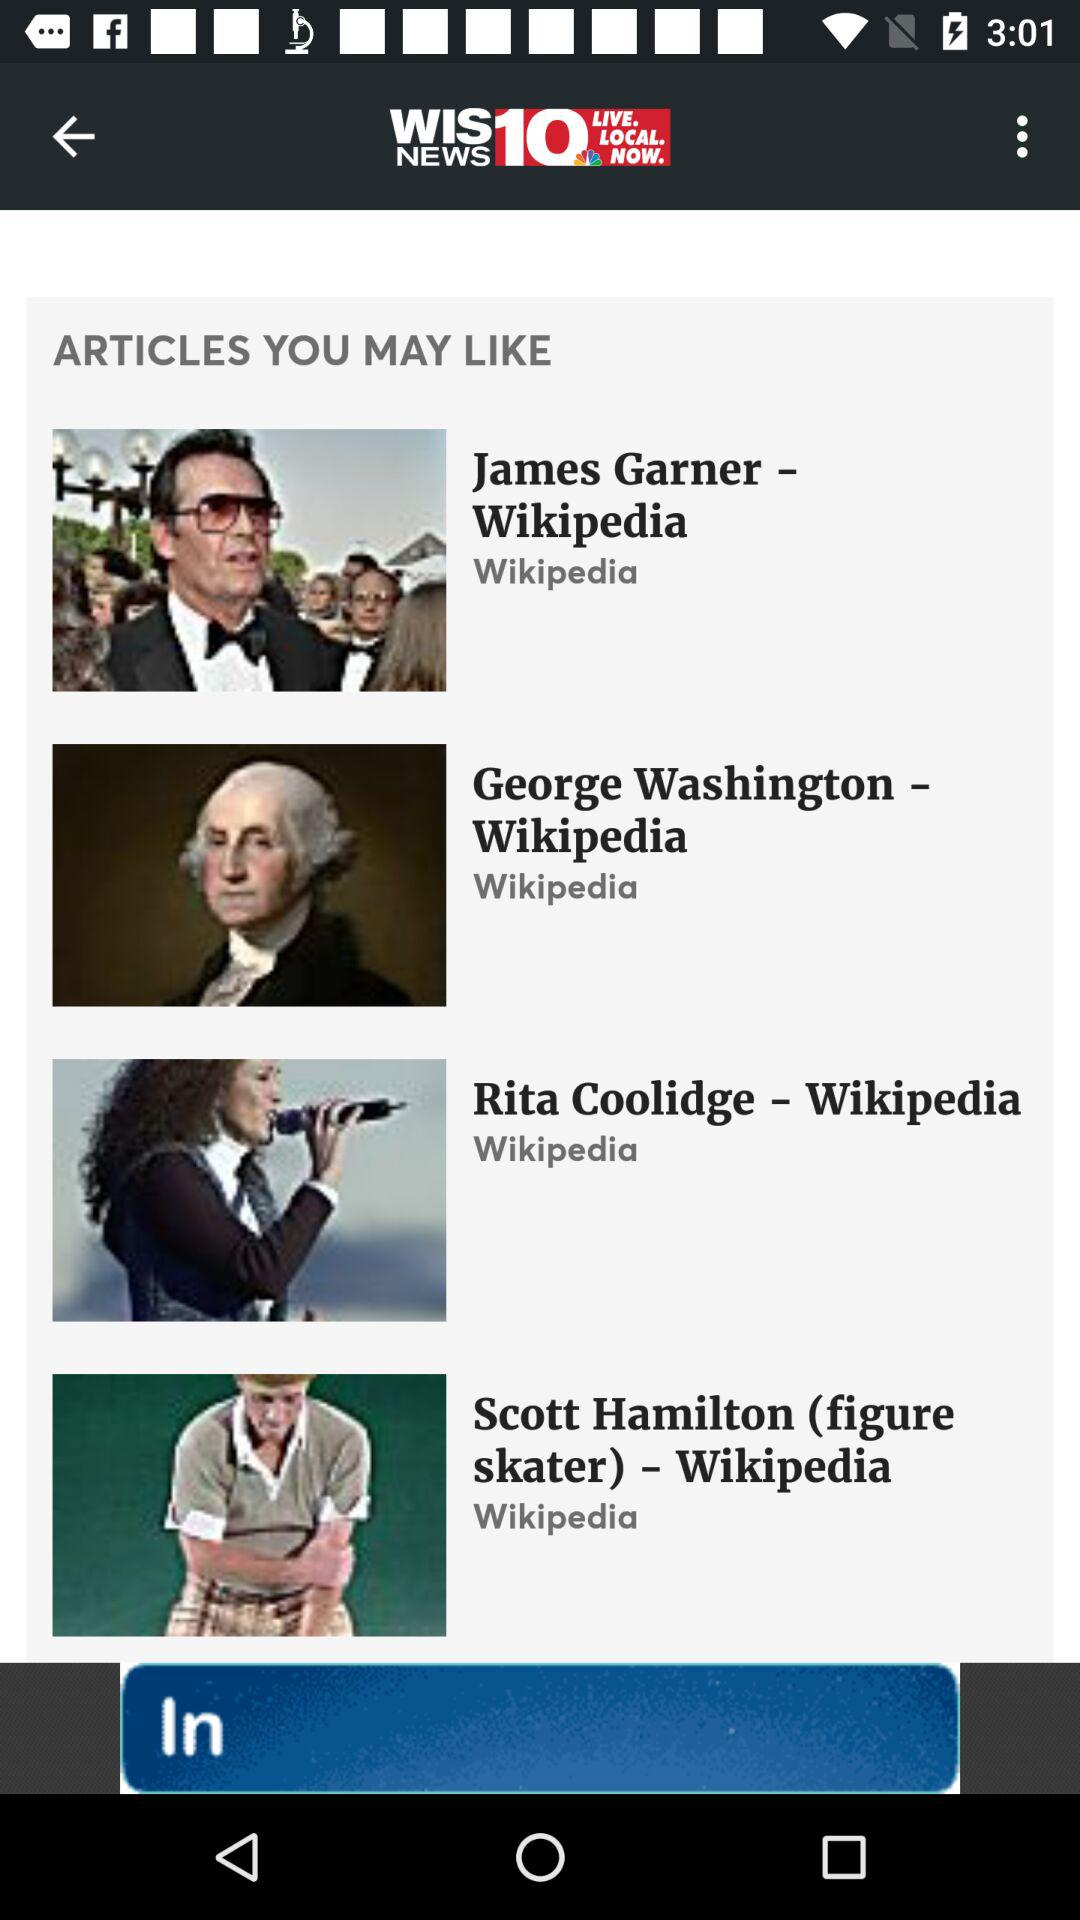What is the app name? The app name is "WIS NEWS 10". 